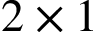Convert formula to latex. <formula><loc_0><loc_0><loc_500><loc_500>2 \times 1</formula> 